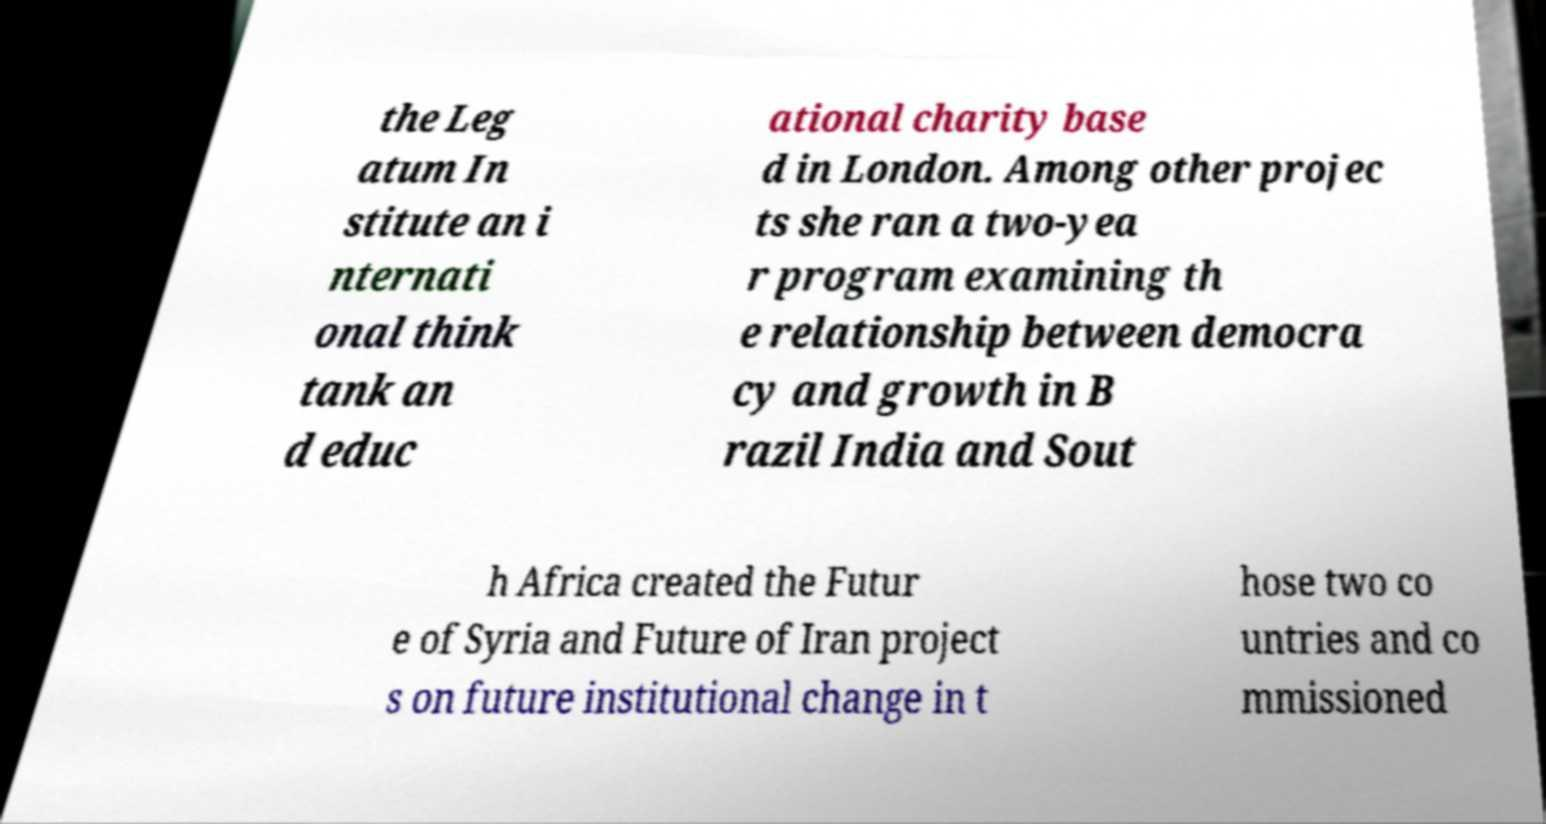Please read and relay the text visible in this image. What does it say? the Leg atum In stitute an i nternati onal think tank an d educ ational charity base d in London. Among other projec ts she ran a two-yea r program examining th e relationship between democra cy and growth in B razil India and Sout h Africa created the Futur e of Syria and Future of Iran project s on future institutional change in t hose two co untries and co mmissioned 